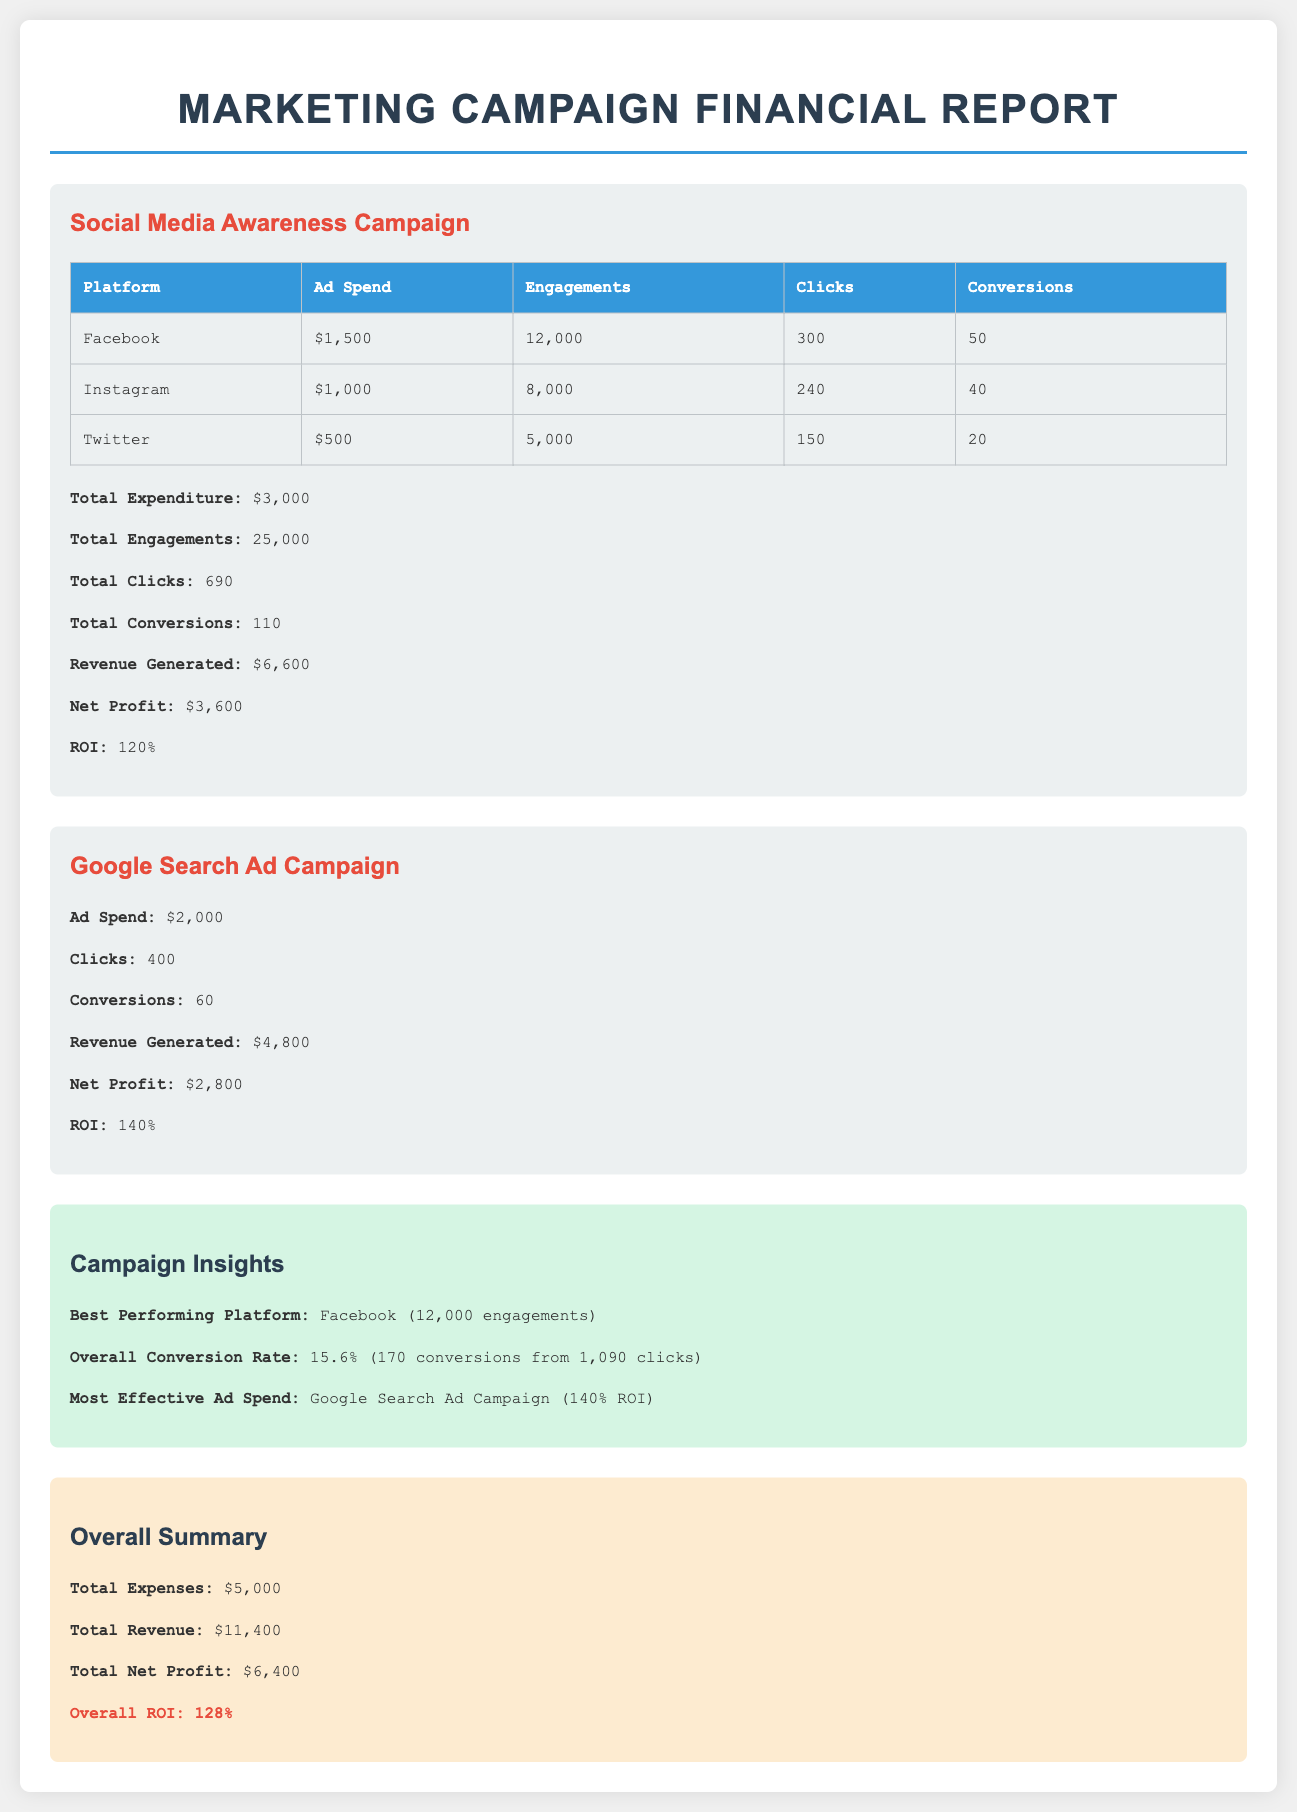What is the total expenditure for the Social Media Awareness Campaign? The total expenditure for the Social Media Awareness Campaign is explicitly stated in the document as $3,000.
Answer: $3,000 What is the ROI for the Google Search Ad Campaign? The ROI for the Google Search Ad Campaign is mentioned directly in the report as 140%.
Answer: 140% Which platform had the highest number of engagements? The document indicates that Facebook had the highest number of engagements, totaling 12,000.
Answer: Facebook What is the overall conversion rate? The overall conversion rate is calculated in the document as 15.6%, based on total conversions and clicks.
Answer: 15.6% What was the total revenue generated from both campaigns? The total revenue is provided as the sum of individual revenues from both campaigns totaling $11,400.
Answer: $11,400 What is the overall net profit reported? The overall net profit is summarized in the document as $6,400, which includes all campaign profits.
Answer: $6,400 What was the ad spend for the Instagram campaign? The ad spend for the Instagram campaign can be found in the report and is listed as $1,000.
Answer: $1,000 